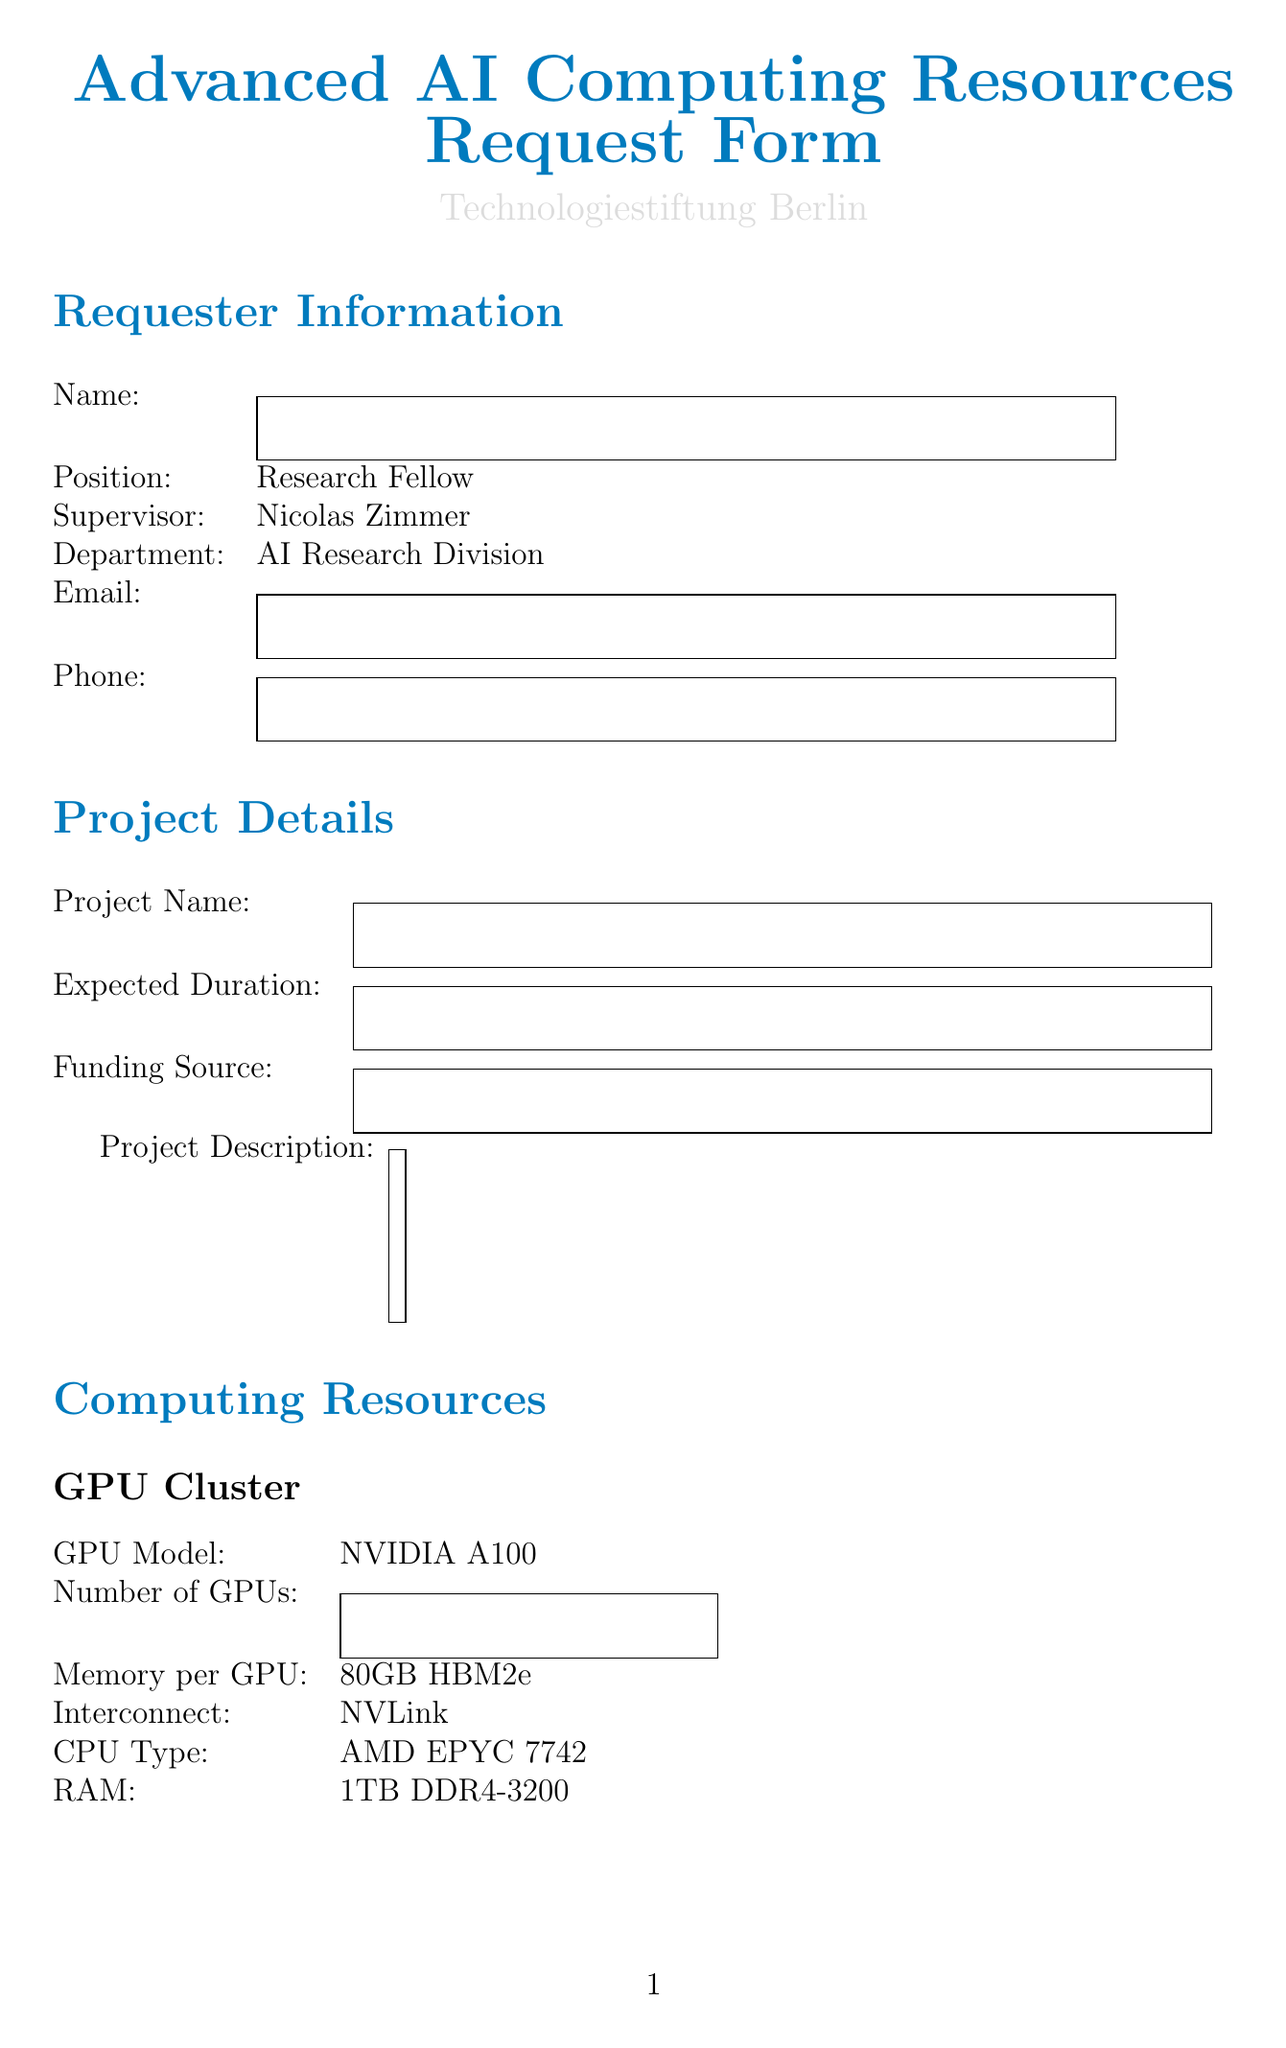what is the GPU model requested? The GPU model requested is specified in the Computing Resources section.
Answer: NVIDIA A100 what type of storage is requested? The type of storage is specified in the High-Performance Storage section of the form.
Answer: NVMe SSD what is the expected read speed of the storage? The expected read speed is mentioned in the specifications of the High-Performance Storage.
Answer: 7000 MB/s what software is required for the project? The required software names are listed under the Specialized AI Software section.
Answer: TensorFlow, PyTorch, CUDA Toolkit, cuDNN who is the supervisor of the requester? The supervisor's name is indicated in the Requester Information section.
Answer: Nicolas Zimmer 